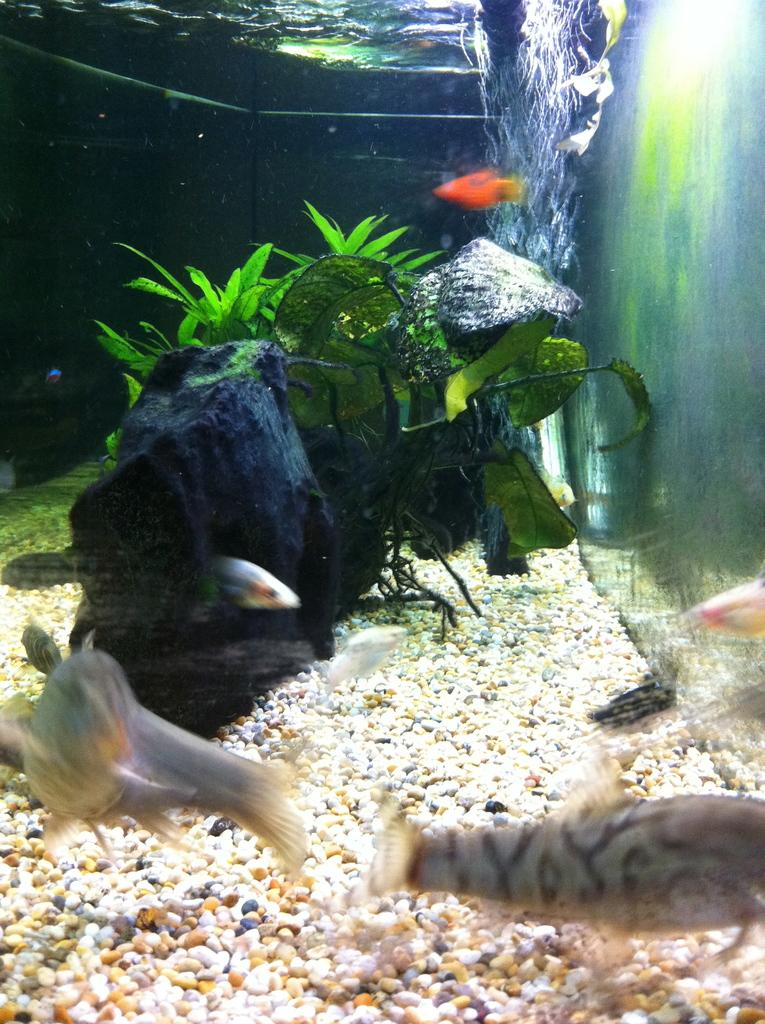What type of animals can be seen in the aquarium in the image? There are fishes in the aquarium in the image. What other objects can be seen in the aquarium besides the fishes? There is a plant and pebbles visible in the aquarium. What is the primary element in the aquarium? There is water in the aquarium. Can you tell me how the fishes are talking to each other in the image? Fishes do not have the ability to talk, so they are not communicating with each other in the image. What type of bone can be seen in the image? There is no bone present in the image; it features an aquarium with fishes, a plant, and pebbles. 